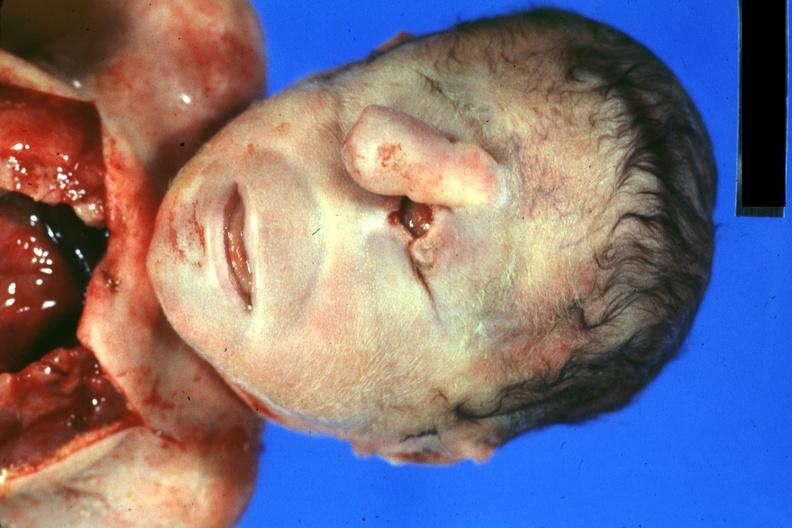s cyclops present?
Answer the question using a single word or phrase. Yes 